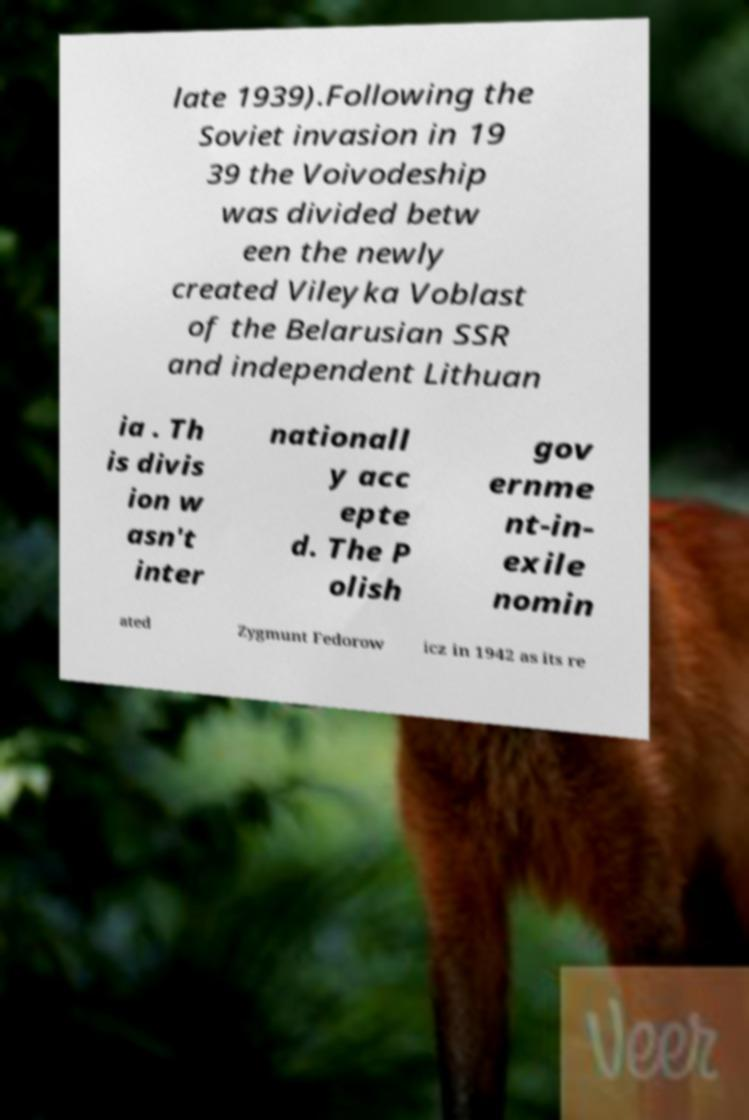Please read and relay the text visible in this image. What does it say? late 1939).Following the Soviet invasion in 19 39 the Voivodeship was divided betw een the newly created Vileyka Voblast of the Belarusian SSR and independent Lithuan ia . Th is divis ion w asn't inter nationall y acc epte d. The P olish gov ernme nt-in- exile nomin ated Zygmunt Fedorow icz in 1942 as its re 